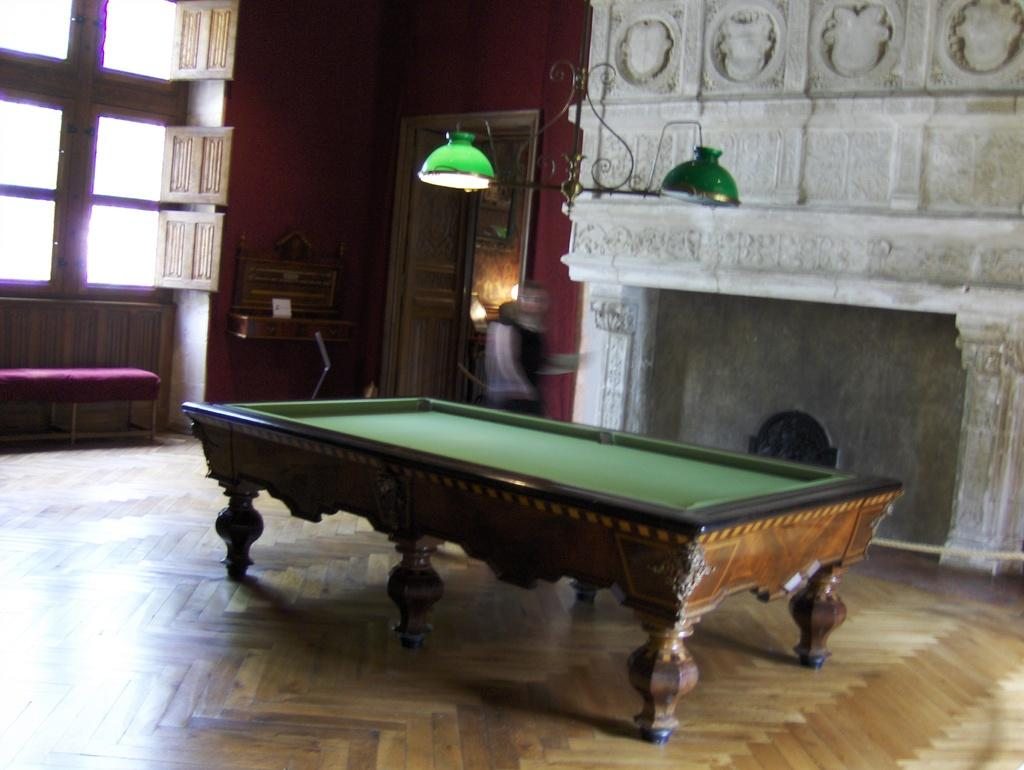What type of game can be played on the board in the image? There is a Snooker Pool board in the image, which is used for playing Snooker or Pool. What is located on the top of the image? There are lights on the top of the image. What can be seen on the left side of the image? There are windows on the left side of the image. What color are the lights in the image? The lights are green in color. What type of knife is being used to cut the nation in the image? There is no knife or nation present in the image; it features a Snooker Pool board, lights, and windows. 